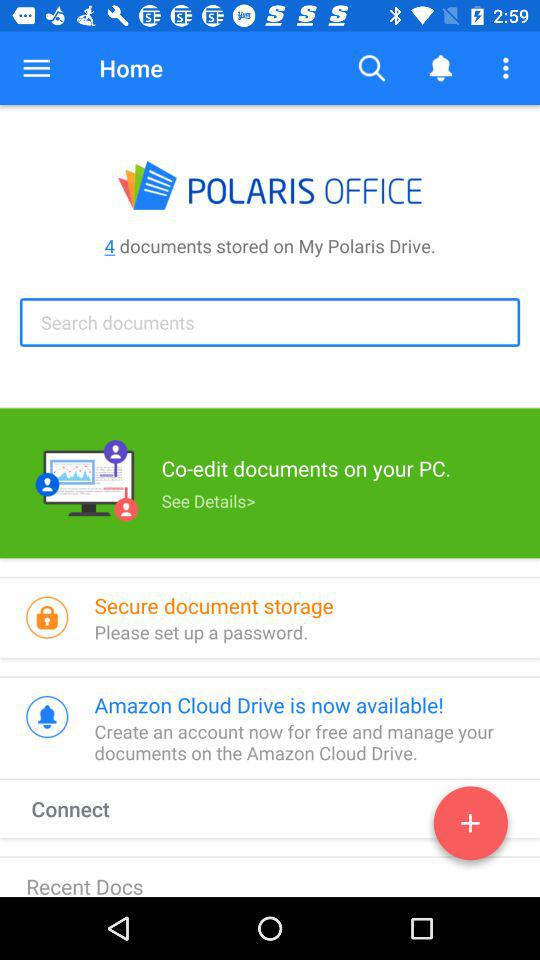How many documents are stored on My Polaris Drive?
Answer the question using a single word or phrase. 4 